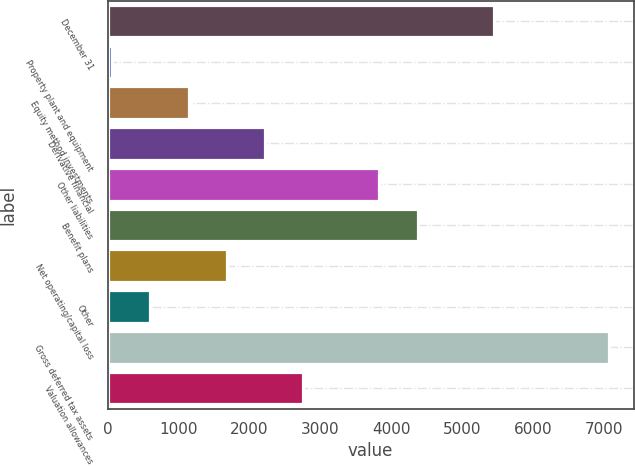Convert chart. <chart><loc_0><loc_0><loc_500><loc_500><bar_chart><fcel>December 31<fcel>Property plant and equipment<fcel>Equity method investments<fcel>Derivative financial<fcel>Other liabilities<fcel>Benefit plans<fcel>Net operating/capital loss<fcel>Other<fcel>Gross deferred tax assets<fcel>Valuation allowances<nl><fcel>5452<fcel>64<fcel>1141.6<fcel>2219.2<fcel>3835.6<fcel>4374.4<fcel>1680.4<fcel>602.8<fcel>7068.4<fcel>2758<nl></chart> 